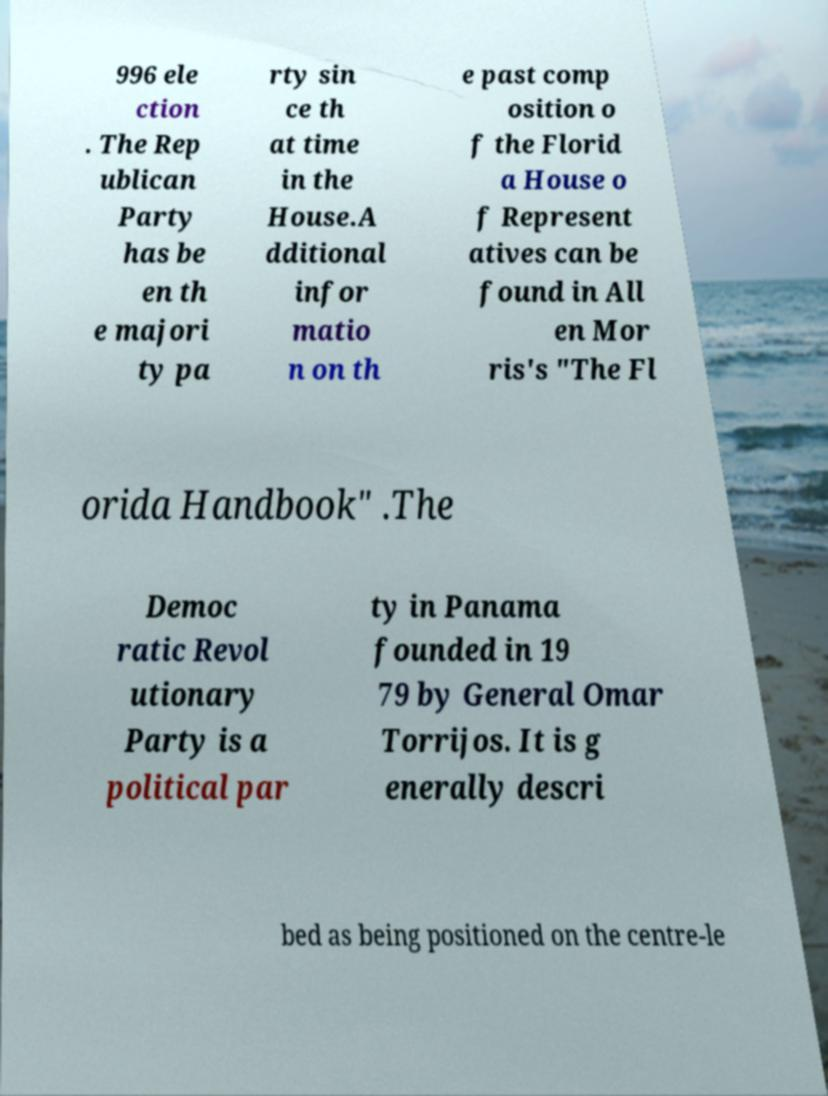Please identify and transcribe the text found in this image. 996 ele ction . The Rep ublican Party has be en th e majori ty pa rty sin ce th at time in the House.A dditional infor matio n on th e past comp osition o f the Florid a House o f Represent atives can be found in All en Mor ris's "The Fl orida Handbook" .The Democ ratic Revol utionary Party is a political par ty in Panama founded in 19 79 by General Omar Torrijos. It is g enerally descri bed as being positioned on the centre-le 